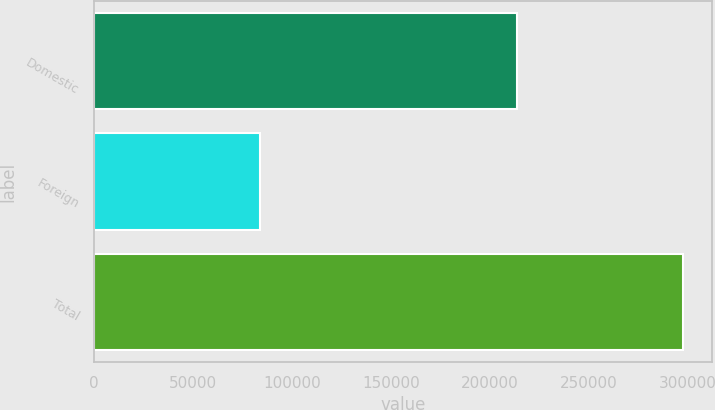<chart> <loc_0><loc_0><loc_500><loc_500><bar_chart><fcel>Domestic<fcel>Foreign<fcel>Total<nl><fcel>213689<fcel>83763<fcel>297452<nl></chart> 